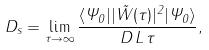<formula> <loc_0><loc_0><loc_500><loc_500>D _ { s } = \lim _ { \tau \to \infty } \frac { \langle \Psi _ { 0 } | | { \vec { W } } ( \tau ) | ^ { 2 } | \Psi _ { 0 } \rangle } { D \, L \, \tau } ,</formula> 